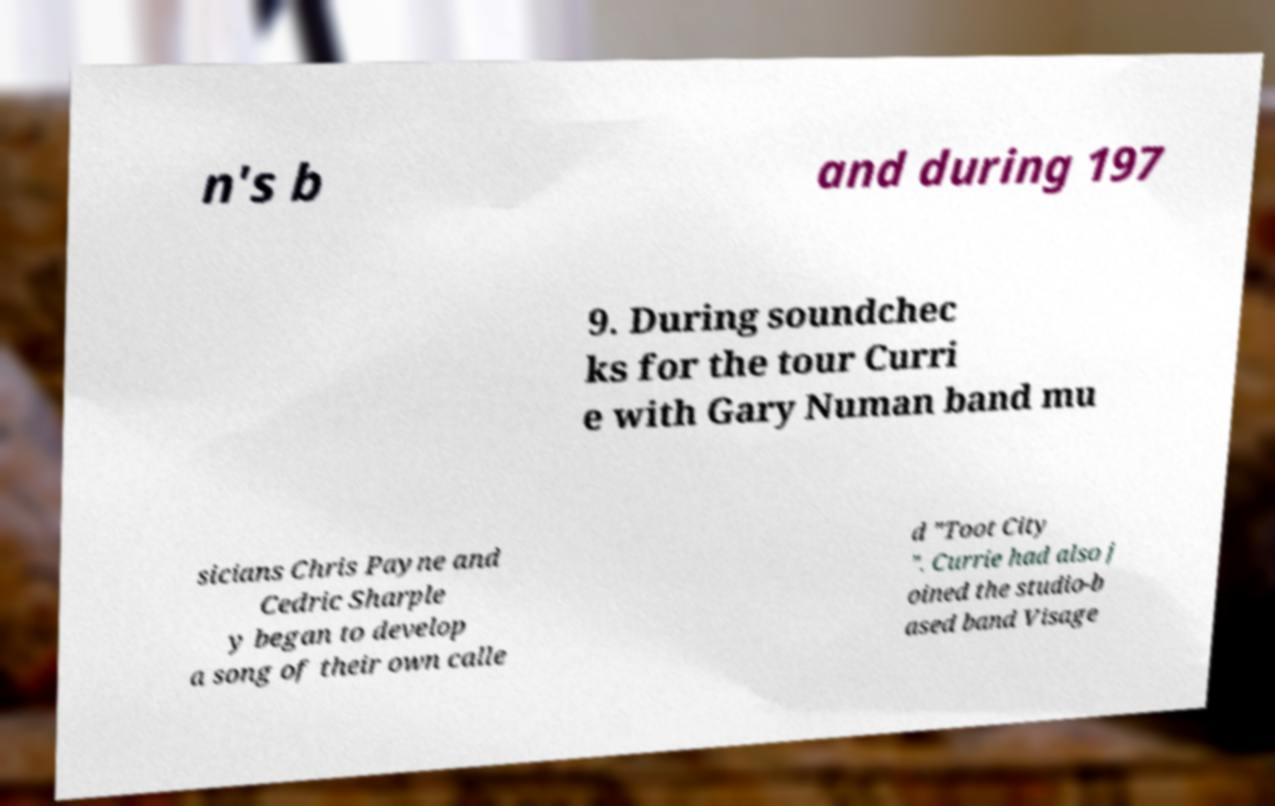Could you extract and type out the text from this image? n's b and during 197 9. During soundchec ks for the tour Curri e with Gary Numan band mu sicians Chris Payne and Cedric Sharple y began to develop a song of their own calle d "Toot City ". Currie had also j oined the studio-b ased band Visage 